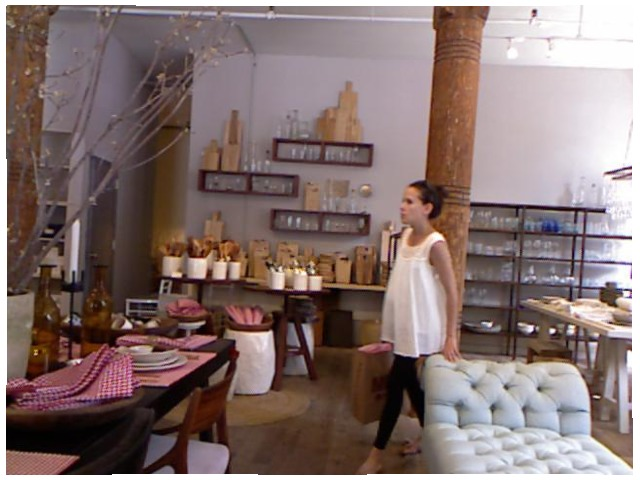<image>
Can you confirm if the person is on the sofa? No. The person is not positioned on the sofa. They may be near each other, but the person is not supported by or resting on top of the sofa. Where is the bag in relation to the woman? Is it to the left of the woman? No. The bag is not to the left of the woman. From this viewpoint, they have a different horizontal relationship. Is the pillar under the chair? No. The pillar is not positioned under the chair. The vertical relationship between these objects is different. Where is the tree branch in relation to the linens? Is it next to the linens? Yes. The tree branch is positioned adjacent to the linens, located nearby in the same general area. 